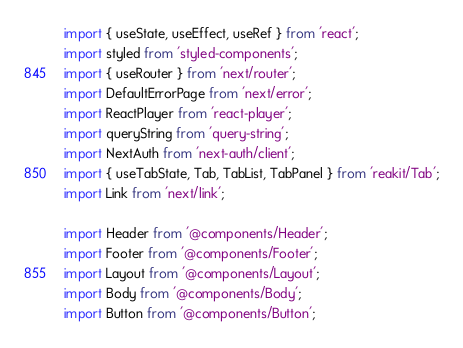<code> <loc_0><loc_0><loc_500><loc_500><_JavaScript_>import { useState, useEffect, useRef } from 'react';
import styled from 'styled-components';
import { useRouter } from 'next/router';
import DefaultErrorPage from 'next/error';
import ReactPlayer from 'react-player';
import queryString from 'query-string';
import NextAuth from 'next-auth/client';
import { useTabState, Tab, TabList, TabPanel } from 'reakit/Tab';
import Link from 'next/link';

import Header from '@components/Header';
import Footer from '@components/Footer';
import Layout from '@components/Layout';
import Body from '@components/Body';
import Button from '@components/Button';</code> 